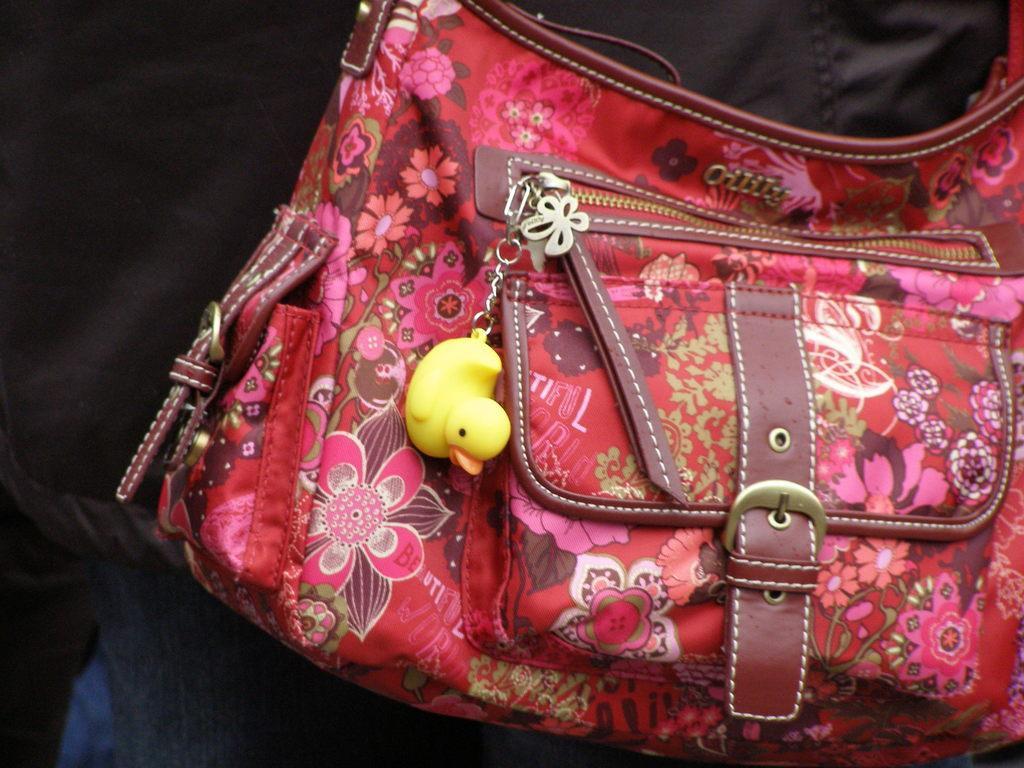Can you describe this image briefly? In this image I see a bag and a duck keychain on it. 